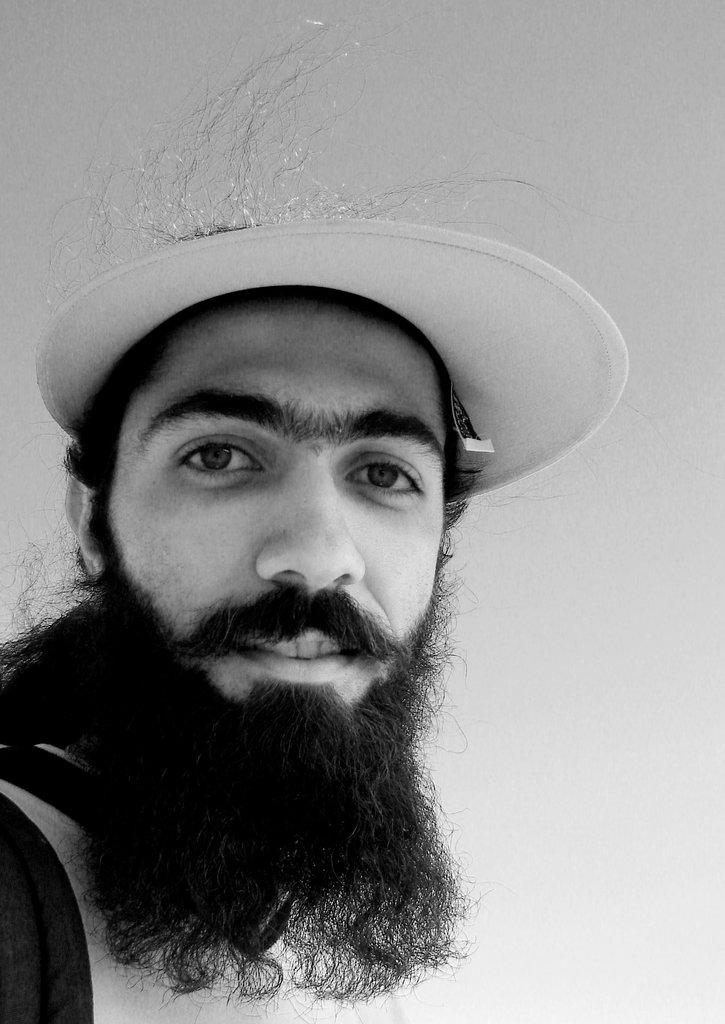What is the color scheme of the image? The image is black and white. Where is the person located in the image? The person is on the left side of the image. What is the person wearing on their head? The person is wearing a cap. What is the person's facial expression in the image? The person is smiling. What color is the background of the image? The background of the image is white in color. Can you see the spy's badge on the person's shoulder in the image? There is no spy or badge present in the image; it features a person wearing a cap and smiling. What type of waves can be seen in the image? There are no waves visible in the image, as it is a black and white photograph of a person wearing a cap and smiling against a white background. 